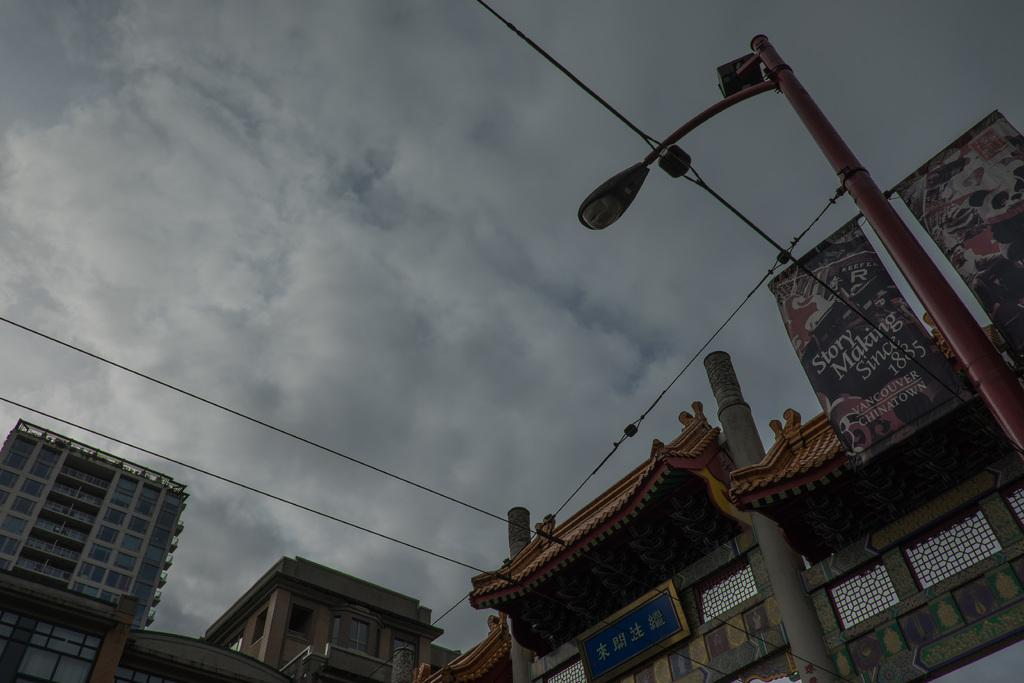What structures are located at the bottom of the image? There are buildings and poles at the bottom of the image. What else can be seen at the bottom of the image? There are banners at the bottom of the image. What is visible at the top of the image? Clouds and the sky are visible at the top of the image. Can you tell me how many aunts are depicted in the image? There are no aunts present in the image. What type of steam is visible coming from the buildings in the image? There is no steam visible in the image; it features buildings, poles, banners, clouds, and the sky. 